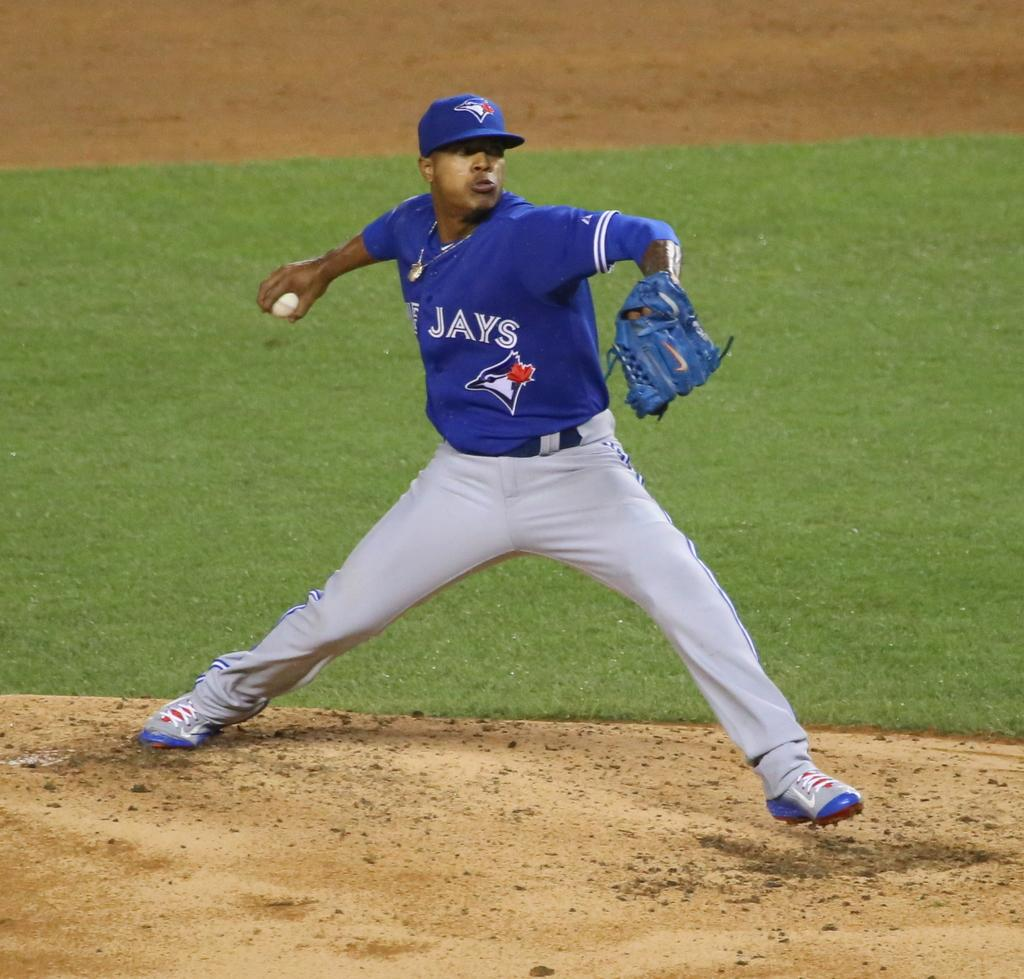<image>
Summarize the visual content of the image. a Blue Jays pitcher that is about to throw the ball 